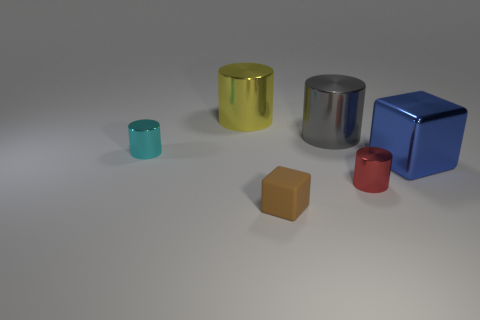There is a cube that is made of the same material as the cyan thing; what color is it?
Your response must be concise. Blue. Is the number of big green objects greater than the number of small blocks?
Offer a very short reply. No. Do the big yellow thing and the small cyan cylinder have the same material?
Provide a succinct answer. Yes. The red object that is the same material as the big gray cylinder is what shape?
Your answer should be very brief. Cylinder. Are there fewer blue shiny balls than metal cubes?
Your response must be concise. Yes. What is the material of the object that is both on the left side of the small red cylinder and in front of the large block?
Your answer should be compact. Rubber. There is a metallic object in front of the thing that is right of the tiny metallic object that is on the right side of the large yellow shiny object; what is its size?
Provide a short and direct response. Small. Does the small red thing have the same shape as the tiny cyan metal object behind the blue thing?
Provide a short and direct response. Yes. What number of tiny metallic cylinders are both on the left side of the tiny red thing and to the right of the big yellow thing?
Your answer should be very brief. 0. What number of green things are tiny shiny cylinders or small matte blocks?
Your response must be concise. 0. 